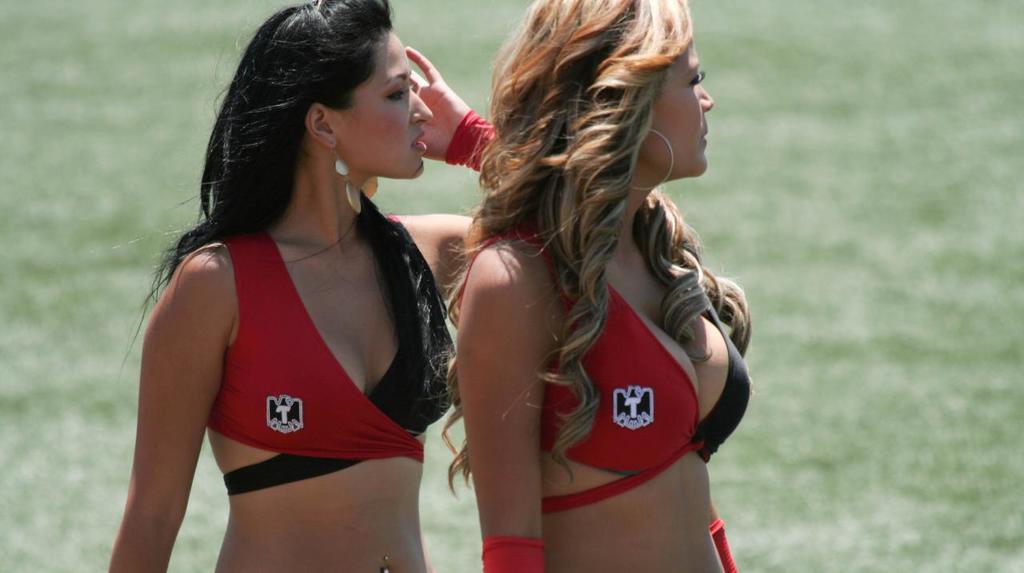What letter is on both of their bikinis?
Offer a terse response. T. 